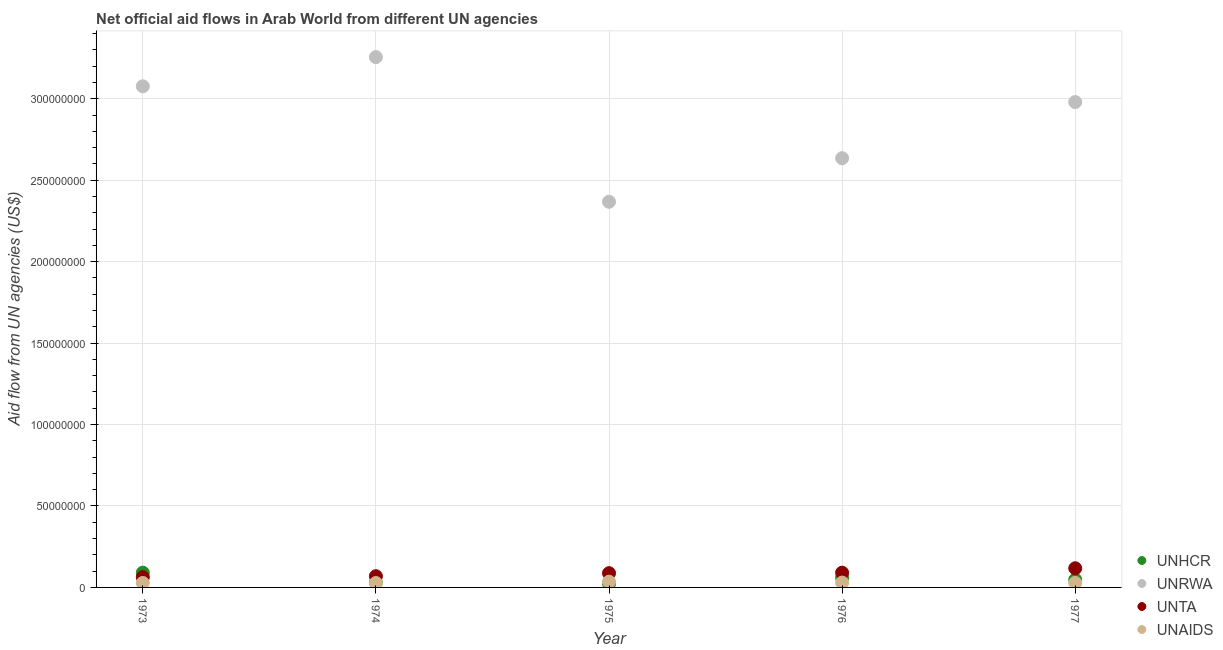How many different coloured dotlines are there?
Make the answer very short. 4. What is the amount of aid given by unhcr in 1976?
Provide a short and direct response. 5.94e+06. Across all years, what is the maximum amount of aid given by unta?
Offer a very short reply. 1.18e+07. Across all years, what is the minimum amount of aid given by unhcr?
Keep it short and to the point. 2.35e+06. In which year was the amount of aid given by unaids minimum?
Keep it short and to the point. 1974. What is the total amount of aid given by unta in the graph?
Provide a succinct answer. 4.28e+07. What is the difference between the amount of aid given by unrwa in 1973 and that in 1975?
Give a very brief answer. 7.09e+07. What is the difference between the amount of aid given by unaids in 1975 and the amount of aid given by unrwa in 1974?
Offer a very short reply. -3.22e+08. What is the average amount of aid given by unaids per year?
Your answer should be very brief. 2.95e+06. In the year 1973, what is the difference between the amount of aid given by unrwa and amount of aid given by unaids?
Your answer should be compact. 3.05e+08. In how many years, is the amount of aid given by unaids greater than 140000000 US$?
Keep it short and to the point. 0. What is the ratio of the amount of aid given by unhcr in 1975 to that in 1976?
Make the answer very short. 0.4. What is the difference between the highest and the second highest amount of aid given by unaids?
Offer a very short reply. 5.60e+05. What is the difference between the highest and the lowest amount of aid given by unta?
Make the answer very short. 5.44e+06. In how many years, is the amount of aid given by unaids greater than the average amount of aid given by unaids taken over all years?
Make the answer very short. 2. Does the amount of aid given by unta monotonically increase over the years?
Provide a short and direct response. Yes. How many dotlines are there?
Give a very brief answer. 4. Does the graph contain any zero values?
Your answer should be very brief. No. Does the graph contain grids?
Ensure brevity in your answer.  Yes. How many legend labels are there?
Provide a succinct answer. 4. What is the title of the graph?
Your answer should be compact. Net official aid flows in Arab World from different UN agencies. Does "European Union" appear as one of the legend labels in the graph?
Give a very brief answer. No. What is the label or title of the Y-axis?
Make the answer very short. Aid flow from UN agencies (US$). What is the Aid flow from UN agencies (US$) in UNHCR in 1973?
Make the answer very short. 9.06e+06. What is the Aid flow from UN agencies (US$) in UNRWA in 1973?
Your answer should be compact. 3.08e+08. What is the Aid flow from UN agencies (US$) of UNTA in 1973?
Your response must be concise. 6.33e+06. What is the Aid flow from UN agencies (US$) in UNAIDS in 1973?
Your response must be concise. 2.74e+06. What is the Aid flow from UN agencies (US$) of UNHCR in 1974?
Provide a succinct answer. 3.05e+06. What is the Aid flow from UN agencies (US$) of UNRWA in 1974?
Offer a terse response. 3.26e+08. What is the Aid flow from UN agencies (US$) in UNTA in 1974?
Offer a terse response. 6.90e+06. What is the Aid flow from UN agencies (US$) of UNAIDS in 1974?
Provide a short and direct response. 2.72e+06. What is the Aid flow from UN agencies (US$) of UNHCR in 1975?
Keep it short and to the point. 2.35e+06. What is the Aid flow from UN agencies (US$) in UNRWA in 1975?
Offer a terse response. 2.37e+08. What is the Aid flow from UN agencies (US$) of UNTA in 1975?
Provide a succinct answer. 8.75e+06. What is the Aid flow from UN agencies (US$) in UNAIDS in 1975?
Offer a terse response. 3.53e+06. What is the Aid flow from UN agencies (US$) of UNHCR in 1976?
Provide a short and direct response. 5.94e+06. What is the Aid flow from UN agencies (US$) in UNRWA in 1976?
Give a very brief answer. 2.64e+08. What is the Aid flow from UN agencies (US$) in UNTA in 1976?
Provide a short and direct response. 9.05e+06. What is the Aid flow from UN agencies (US$) of UNAIDS in 1976?
Give a very brief answer. 2.97e+06. What is the Aid flow from UN agencies (US$) in UNHCR in 1977?
Keep it short and to the point. 4.75e+06. What is the Aid flow from UN agencies (US$) in UNRWA in 1977?
Your answer should be compact. 2.98e+08. What is the Aid flow from UN agencies (US$) of UNTA in 1977?
Give a very brief answer. 1.18e+07. What is the Aid flow from UN agencies (US$) of UNAIDS in 1977?
Offer a terse response. 2.80e+06. Across all years, what is the maximum Aid flow from UN agencies (US$) of UNHCR?
Provide a short and direct response. 9.06e+06. Across all years, what is the maximum Aid flow from UN agencies (US$) in UNRWA?
Offer a terse response. 3.26e+08. Across all years, what is the maximum Aid flow from UN agencies (US$) in UNTA?
Your answer should be very brief. 1.18e+07. Across all years, what is the maximum Aid flow from UN agencies (US$) of UNAIDS?
Ensure brevity in your answer.  3.53e+06. Across all years, what is the minimum Aid flow from UN agencies (US$) of UNHCR?
Provide a succinct answer. 2.35e+06. Across all years, what is the minimum Aid flow from UN agencies (US$) of UNRWA?
Ensure brevity in your answer.  2.37e+08. Across all years, what is the minimum Aid flow from UN agencies (US$) of UNTA?
Your answer should be very brief. 6.33e+06. Across all years, what is the minimum Aid flow from UN agencies (US$) in UNAIDS?
Offer a very short reply. 2.72e+06. What is the total Aid flow from UN agencies (US$) in UNHCR in the graph?
Provide a short and direct response. 2.52e+07. What is the total Aid flow from UN agencies (US$) in UNRWA in the graph?
Make the answer very short. 1.43e+09. What is the total Aid flow from UN agencies (US$) of UNTA in the graph?
Your answer should be compact. 4.28e+07. What is the total Aid flow from UN agencies (US$) of UNAIDS in the graph?
Keep it short and to the point. 1.48e+07. What is the difference between the Aid flow from UN agencies (US$) of UNHCR in 1973 and that in 1974?
Provide a succinct answer. 6.01e+06. What is the difference between the Aid flow from UN agencies (US$) of UNRWA in 1973 and that in 1974?
Offer a very short reply. -1.79e+07. What is the difference between the Aid flow from UN agencies (US$) of UNTA in 1973 and that in 1974?
Your response must be concise. -5.70e+05. What is the difference between the Aid flow from UN agencies (US$) of UNAIDS in 1973 and that in 1974?
Ensure brevity in your answer.  2.00e+04. What is the difference between the Aid flow from UN agencies (US$) in UNHCR in 1973 and that in 1975?
Offer a very short reply. 6.71e+06. What is the difference between the Aid flow from UN agencies (US$) in UNRWA in 1973 and that in 1975?
Your response must be concise. 7.09e+07. What is the difference between the Aid flow from UN agencies (US$) in UNTA in 1973 and that in 1975?
Make the answer very short. -2.42e+06. What is the difference between the Aid flow from UN agencies (US$) in UNAIDS in 1973 and that in 1975?
Offer a very short reply. -7.90e+05. What is the difference between the Aid flow from UN agencies (US$) in UNHCR in 1973 and that in 1976?
Offer a very short reply. 3.12e+06. What is the difference between the Aid flow from UN agencies (US$) in UNRWA in 1973 and that in 1976?
Give a very brief answer. 4.42e+07. What is the difference between the Aid flow from UN agencies (US$) of UNTA in 1973 and that in 1976?
Your response must be concise. -2.72e+06. What is the difference between the Aid flow from UN agencies (US$) of UNHCR in 1973 and that in 1977?
Offer a very short reply. 4.31e+06. What is the difference between the Aid flow from UN agencies (US$) in UNRWA in 1973 and that in 1977?
Offer a very short reply. 9.68e+06. What is the difference between the Aid flow from UN agencies (US$) in UNTA in 1973 and that in 1977?
Offer a terse response. -5.44e+06. What is the difference between the Aid flow from UN agencies (US$) of UNHCR in 1974 and that in 1975?
Your answer should be compact. 7.00e+05. What is the difference between the Aid flow from UN agencies (US$) in UNRWA in 1974 and that in 1975?
Offer a terse response. 8.88e+07. What is the difference between the Aid flow from UN agencies (US$) in UNTA in 1974 and that in 1975?
Ensure brevity in your answer.  -1.85e+06. What is the difference between the Aid flow from UN agencies (US$) of UNAIDS in 1974 and that in 1975?
Give a very brief answer. -8.10e+05. What is the difference between the Aid flow from UN agencies (US$) in UNHCR in 1974 and that in 1976?
Give a very brief answer. -2.89e+06. What is the difference between the Aid flow from UN agencies (US$) of UNRWA in 1974 and that in 1976?
Provide a short and direct response. 6.20e+07. What is the difference between the Aid flow from UN agencies (US$) of UNTA in 1974 and that in 1976?
Your answer should be compact. -2.15e+06. What is the difference between the Aid flow from UN agencies (US$) in UNAIDS in 1974 and that in 1976?
Offer a very short reply. -2.50e+05. What is the difference between the Aid flow from UN agencies (US$) of UNHCR in 1974 and that in 1977?
Offer a terse response. -1.70e+06. What is the difference between the Aid flow from UN agencies (US$) in UNRWA in 1974 and that in 1977?
Give a very brief answer. 2.76e+07. What is the difference between the Aid flow from UN agencies (US$) of UNTA in 1974 and that in 1977?
Make the answer very short. -4.87e+06. What is the difference between the Aid flow from UN agencies (US$) in UNHCR in 1975 and that in 1976?
Give a very brief answer. -3.59e+06. What is the difference between the Aid flow from UN agencies (US$) in UNRWA in 1975 and that in 1976?
Give a very brief answer. -2.67e+07. What is the difference between the Aid flow from UN agencies (US$) in UNAIDS in 1975 and that in 1976?
Keep it short and to the point. 5.60e+05. What is the difference between the Aid flow from UN agencies (US$) in UNHCR in 1975 and that in 1977?
Keep it short and to the point. -2.40e+06. What is the difference between the Aid flow from UN agencies (US$) in UNRWA in 1975 and that in 1977?
Your answer should be very brief. -6.12e+07. What is the difference between the Aid flow from UN agencies (US$) in UNTA in 1975 and that in 1977?
Your answer should be compact. -3.02e+06. What is the difference between the Aid flow from UN agencies (US$) of UNAIDS in 1975 and that in 1977?
Keep it short and to the point. 7.30e+05. What is the difference between the Aid flow from UN agencies (US$) of UNHCR in 1976 and that in 1977?
Make the answer very short. 1.19e+06. What is the difference between the Aid flow from UN agencies (US$) of UNRWA in 1976 and that in 1977?
Offer a very short reply. -3.45e+07. What is the difference between the Aid flow from UN agencies (US$) in UNTA in 1976 and that in 1977?
Your response must be concise. -2.72e+06. What is the difference between the Aid flow from UN agencies (US$) in UNAIDS in 1976 and that in 1977?
Keep it short and to the point. 1.70e+05. What is the difference between the Aid flow from UN agencies (US$) in UNHCR in 1973 and the Aid flow from UN agencies (US$) in UNRWA in 1974?
Your answer should be compact. -3.17e+08. What is the difference between the Aid flow from UN agencies (US$) in UNHCR in 1973 and the Aid flow from UN agencies (US$) in UNTA in 1974?
Your answer should be very brief. 2.16e+06. What is the difference between the Aid flow from UN agencies (US$) in UNHCR in 1973 and the Aid flow from UN agencies (US$) in UNAIDS in 1974?
Ensure brevity in your answer.  6.34e+06. What is the difference between the Aid flow from UN agencies (US$) of UNRWA in 1973 and the Aid flow from UN agencies (US$) of UNTA in 1974?
Provide a short and direct response. 3.01e+08. What is the difference between the Aid flow from UN agencies (US$) in UNRWA in 1973 and the Aid flow from UN agencies (US$) in UNAIDS in 1974?
Offer a very short reply. 3.05e+08. What is the difference between the Aid flow from UN agencies (US$) in UNTA in 1973 and the Aid flow from UN agencies (US$) in UNAIDS in 1974?
Your response must be concise. 3.61e+06. What is the difference between the Aid flow from UN agencies (US$) in UNHCR in 1973 and the Aid flow from UN agencies (US$) in UNRWA in 1975?
Offer a very short reply. -2.28e+08. What is the difference between the Aid flow from UN agencies (US$) in UNHCR in 1973 and the Aid flow from UN agencies (US$) in UNTA in 1975?
Your answer should be very brief. 3.10e+05. What is the difference between the Aid flow from UN agencies (US$) in UNHCR in 1973 and the Aid flow from UN agencies (US$) in UNAIDS in 1975?
Offer a terse response. 5.53e+06. What is the difference between the Aid flow from UN agencies (US$) in UNRWA in 1973 and the Aid flow from UN agencies (US$) in UNTA in 1975?
Your answer should be very brief. 2.99e+08. What is the difference between the Aid flow from UN agencies (US$) in UNRWA in 1973 and the Aid flow from UN agencies (US$) in UNAIDS in 1975?
Make the answer very short. 3.04e+08. What is the difference between the Aid flow from UN agencies (US$) of UNTA in 1973 and the Aid flow from UN agencies (US$) of UNAIDS in 1975?
Make the answer very short. 2.80e+06. What is the difference between the Aid flow from UN agencies (US$) of UNHCR in 1973 and the Aid flow from UN agencies (US$) of UNRWA in 1976?
Provide a short and direct response. -2.54e+08. What is the difference between the Aid flow from UN agencies (US$) in UNHCR in 1973 and the Aid flow from UN agencies (US$) in UNAIDS in 1976?
Give a very brief answer. 6.09e+06. What is the difference between the Aid flow from UN agencies (US$) in UNRWA in 1973 and the Aid flow from UN agencies (US$) in UNTA in 1976?
Your response must be concise. 2.99e+08. What is the difference between the Aid flow from UN agencies (US$) of UNRWA in 1973 and the Aid flow from UN agencies (US$) of UNAIDS in 1976?
Your answer should be very brief. 3.05e+08. What is the difference between the Aid flow from UN agencies (US$) in UNTA in 1973 and the Aid flow from UN agencies (US$) in UNAIDS in 1976?
Ensure brevity in your answer.  3.36e+06. What is the difference between the Aid flow from UN agencies (US$) in UNHCR in 1973 and the Aid flow from UN agencies (US$) in UNRWA in 1977?
Offer a terse response. -2.89e+08. What is the difference between the Aid flow from UN agencies (US$) of UNHCR in 1973 and the Aid flow from UN agencies (US$) of UNTA in 1977?
Ensure brevity in your answer.  -2.71e+06. What is the difference between the Aid flow from UN agencies (US$) in UNHCR in 1973 and the Aid flow from UN agencies (US$) in UNAIDS in 1977?
Your answer should be very brief. 6.26e+06. What is the difference between the Aid flow from UN agencies (US$) of UNRWA in 1973 and the Aid flow from UN agencies (US$) of UNTA in 1977?
Your answer should be compact. 2.96e+08. What is the difference between the Aid flow from UN agencies (US$) of UNRWA in 1973 and the Aid flow from UN agencies (US$) of UNAIDS in 1977?
Ensure brevity in your answer.  3.05e+08. What is the difference between the Aid flow from UN agencies (US$) in UNTA in 1973 and the Aid flow from UN agencies (US$) in UNAIDS in 1977?
Your answer should be compact. 3.53e+06. What is the difference between the Aid flow from UN agencies (US$) in UNHCR in 1974 and the Aid flow from UN agencies (US$) in UNRWA in 1975?
Your response must be concise. -2.34e+08. What is the difference between the Aid flow from UN agencies (US$) in UNHCR in 1974 and the Aid flow from UN agencies (US$) in UNTA in 1975?
Provide a succinct answer. -5.70e+06. What is the difference between the Aid flow from UN agencies (US$) in UNHCR in 1974 and the Aid flow from UN agencies (US$) in UNAIDS in 1975?
Your response must be concise. -4.80e+05. What is the difference between the Aid flow from UN agencies (US$) of UNRWA in 1974 and the Aid flow from UN agencies (US$) of UNTA in 1975?
Ensure brevity in your answer.  3.17e+08. What is the difference between the Aid flow from UN agencies (US$) in UNRWA in 1974 and the Aid flow from UN agencies (US$) in UNAIDS in 1975?
Provide a succinct answer. 3.22e+08. What is the difference between the Aid flow from UN agencies (US$) in UNTA in 1974 and the Aid flow from UN agencies (US$) in UNAIDS in 1975?
Keep it short and to the point. 3.37e+06. What is the difference between the Aid flow from UN agencies (US$) of UNHCR in 1974 and the Aid flow from UN agencies (US$) of UNRWA in 1976?
Make the answer very short. -2.60e+08. What is the difference between the Aid flow from UN agencies (US$) in UNHCR in 1974 and the Aid flow from UN agencies (US$) in UNTA in 1976?
Ensure brevity in your answer.  -6.00e+06. What is the difference between the Aid flow from UN agencies (US$) in UNRWA in 1974 and the Aid flow from UN agencies (US$) in UNTA in 1976?
Offer a terse response. 3.17e+08. What is the difference between the Aid flow from UN agencies (US$) of UNRWA in 1974 and the Aid flow from UN agencies (US$) of UNAIDS in 1976?
Keep it short and to the point. 3.23e+08. What is the difference between the Aid flow from UN agencies (US$) of UNTA in 1974 and the Aid flow from UN agencies (US$) of UNAIDS in 1976?
Ensure brevity in your answer.  3.93e+06. What is the difference between the Aid flow from UN agencies (US$) of UNHCR in 1974 and the Aid flow from UN agencies (US$) of UNRWA in 1977?
Ensure brevity in your answer.  -2.95e+08. What is the difference between the Aid flow from UN agencies (US$) of UNHCR in 1974 and the Aid flow from UN agencies (US$) of UNTA in 1977?
Make the answer very short. -8.72e+06. What is the difference between the Aid flow from UN agencies (US$) of UNRWA in 1974 and the Aid flow from UN agencies (US$) of UNTA in 1977?
Provide a short and direct response. 3.14e+08. What is the difference between the Aid flow from UN agencies (US$) in UNRWA in 1974 and the Aid flow from UN agencies (US$) in UNAIDS in 1977?
Offer a terse response. 3.23e+08. What is the difference between the Aid flow from UN agencies (US$) of UNTA in 1974 and the Aid flow from UN agencies (US$) of UNAIDS in 1977?
Your response must be concise. 4.10e+06. What is the difference between the Aid flow from UN agencies (US$) in UNHCR in 1975 and the Aid flow from UN agencies (US$) in UNRWA in 1976?
Provide a succinct answer. -2.61e+08. What is the difference between the Aid flow from UN agencies (US$) of UNHCR in 1975 and the Aid flow from UN agencies (US$) of UNTA in 1976?
Give a very brief answer. -6.70e+06. What is the difference between the Aid flow from UN agencies (US$) of UNHCR in 1975 and the Aid flow from UN agencies (US$) of UNAIDS in 1976?
Provide a short and direct response. -6.20e+05. What is the difference between the Aid flow from UN agencies (US$) in UNRWA in 1975 and the Aid flow from UN agencies (US$) in UNTA in 1976?
Your response must be concise. 2.28e+08. What is the difference between the Aid flow from UN agencies (US$) of UNRWA in 1975 and the Aid flow from UN agencies (US$) of UNAIDS in 1976?
Ensure brevity in your answer.  2.34e+08. What is the difference between the Aid flow from UN agencies (US$) in UNTA in 1975 and the Aid flow from UN agencies (US$) in UNAIDS in 1976?
Keep it short and to the point. 5.78e+06. What is the difference between the Aid flow from UN agencies (US$) of UNHCR in 1975 and the Aid flow from UN agencies (US$) of UNRWA in 1977?
Provide a succinct answer. -2.96e+08. What is the difference between the Aid flow from UN agencies (US$) in UNHCR in 1975 and the Aid flow from UN agencies (US$) in UNTA in 1977?
Provide a succinct answer. -9.42e+06. What is the difference between the Aid flow from UN agencies (US$) of UNHCR in 1975 and the Aid flow from UN agencies (US$) of UNAIDS in 1977?
Offer a very short reply. -4.50e+05. What is the difference between the Aid flow from UN agencies (US$) of UNRWA in 1975 and the Aid flow from UN agencies (US$) of UNTA in 1977?
Keep it short and to the point. 2.25e+08. What is the difference between the Aid flow from UN agencies (US$) in UNRWA in 1975 and the Aid flow from UN agencies (US$) in UNAIDS in 1977?
Your answer should be compact. 2.34e+08. What is the difference between the Aid flow from UN agencies (US$) of UNTA in 1975 and the Aid flow from UN agencies (US$) of UNAIDS in 1977?
Provide a succinct answer. 5.95e+06. What is the difference between the Aid flow from UN agencies (US$) of UNHCR in 1976 and the Aid flow from UN agencies (US$) of UNRWA in 1977?
Keep it short and to the point. -2.92e+08. What is the difference between the Aid flow from UN agencies (US$) of UNHCR in 1976 and the Aid flow from UN agencies (US$) of UNTA in 1977?
Offer a very short reply. -5.83e+06. What is the difference between the Aid flow from UN agencies (US$) of UNHCR in 1976 and the Aid flow from UN agencies (US$) of UNAIDS in 1977?
Make the answer very short. 3.14e+06. What is the difference between the Aid flow from UN agencies (US$) in UNRWA in 1976 and the Aid flow from UN agencies (US$) in UNTA in 1977?
Keep it short and to the point. 2.52e+08. What is the difference between the Aid flow from UN agencies (US$) in UNRWA in 1976 and the Aid flow from UN agencies (US$) in UNAIDS in 1977?
Provide a succinct answer. 2.61e+08. What is the difference between the Aid flow from UN agencies (US$) in UNTA in 1976 and the Aid flow from UN agencies (US$) in UNAIDS in 1977?
Your answer should be very brief. 6.25e+06. What is the average Aid flow from UN agencies (US$) in UNHCR per year?
Make the answer very short. 5.03e+06. What is the average Aid flow from UN agencies (US$) in UNRWA per year?
Ensure brevity in your answer.  2.86e+08. What is the average Aid flow from UN agencies (US$) of UNTA per year?
Make the answer very short. 8.56e+06. What is the average Aid flow from UN agencies (US$) of UNAIDS per year?
Keep it short and to the point. 2.95e+06. In the year 1973, what is the difference between the Aid flow from UN agencies (US$) of UNHCR and Aid flow from UN agencies (US$) of UNRWA?
Offer a terse response. -2.99e+08. In the year 1973, what is the difference between the Aid flow from UN agencies (US$) of UNHCR and Aid flow from UN agencies (US$) of UNTA?
Offer a very short reply. 2.73e+06. In the year 1973, what is the difference between the Aid flow from UN agencies (US$) in UNHCR and Aid flow from UN agencies (US$) in UNAIDS?
Your answer should be compact. 6.32e+06. In the year 1973, what is the difference between the Aid flow from UN agencies (US$) of UNRWA and Aid flow from UN agencies (US$) of UNTA?
Your answer should be compact. 3.01e+08. In the year 1973, what is the difference between the Aid flow from UN agencies (US$) of UNRWA and Aid flow from UN agencies (US$) of UNAIDS?
Your answer should be compact. 3.05e+08. In the year 1973, what is the difference between the Aid flow from UN agencies (US$) in UNTA and Aid flow from UN agencies (US$) in UNAIDS?
Ensure brevity in your answer.  3.59e+06. In the year 1974, what is the difference between the Aid flow from UN agencies (US$) in UNHCR and Aid flow from UN agencies (US$) in UNRWA?
Your answer should be compact. -3.23e+08. In the year 1974, what is the difference between the Aid flow from UN agencies (US$) of UNHCR and Aid flow from UN agencies (US$) of UNTA?
Provide a short and direct response. -3.85e+06. In the year 1974, what is the difference between the Aid flow from UN agencies (US$) of UNHCR and Aid flow from UN agencies (US$) of UNAIDS?
Your response must be concise. 3.30e+05. In the year 1974, what is the difference between the Aid flow from UN agencies (US$) of UNRWA and Aid flow from UN agencies (US$) of UNTA?
Ensure brevity in your answer.  3.19e+08. In the year 1974, what is the difference between the Aid flow from UN agencies (US$) in UNRWA and Aid flow from UN agencies (US$) in UNAIDS?
Offer a very short reply. 3.23e+08. In the year 1974, what is the difference between the Aid flow from UN agencies (US$) of UNTA and Aid flow from UN agencies (US$) of UNAIDS?
Your answer should be very brief. 4.18e+06. In the year 1975, what is the difference between the Aid flow from UN agencies (US$) in UNHCR and Aid flow from UN agencies (US$) in UNRWA?
Provide a short and direct response. -2.34e+08. In the year 1975, what is the difference between the Aid flow from UN agencies (US$) in UNHCR and Aid flow from UN agencies (US$) in UNTA?
Your response must be concise. -6.40e+06. In the year 1975, what is the difference between the Aid flow from UN agencies (US$) in UNHCR and Aid flow from UN agencies (US$) in UNAIDS?
Give a very brief answer. -1.18e+06. In the year 1975, what is the difference between the Aid flow from UN agencies (US$) of UNRWA and Aid flow from UN agencies (US$) of UNTA?
Provide a succinct answer. 2.28e+08. In the year 1975, what is the difference between the Aid flow from UN agencies (US$) in UNRWA and Aid flow from UN agencies (US$) in UNAIDS?
Your answer should be compact. 2.33e+08. In the year 1975, what is the difference between the Aid flow from UN agencies (US$) of UNTA and Aid flow from UN agencies (US$) of UNAIDS?
Offer a very short reply. 5.22e+06. In the year 1976, what is the difference between the Aid flow from UN agencies (US$) of UNHCR and Aid flow from UN agencies (US$) of UNRWA?
Give a very brief answer. -2.58e+08. In the year 1976, what is the difference between the Aid flow from UN agencies (US$) of UNHCR and Aid flow from UN agencies (US$) of UNTA?
Ensure brevity in your answer.  -3.11e+06. In the year 1976, what is the difference between the Aid flow from UN agencies (US$) in UNHCR and Aid flow from UN agencies (US$) in UNAIDS?
Offer a terse response. 2.97e+06. In the year 1976, what is the difference between the Aid flow from UN agencies (US$) in UNRWA and Aid flow from UN agencies (US$) in UNTA?
Your response must be concise. 2.54e+08. In the year 1976, what is the difference between the Aid flow from UN agencies (US$) in UNRWA and Aid flow from UN agencies (US$) in UNAIDS?
Provide a short and direct response. 2.61e+08. In the year 1976, what is the difference between the Aid flow from UN agencies (US$) in UNTA and Aid flow from UN agencies (US$) in UNAIDS?
Keep it short and to the point. 6.08e+06. In the year 1977, what is the difference between the Aid flow from UN agencies (US$) of UNHCR and Aid flow from UN agencies (US$) of UNRWA?
Ensure brevity in your answer.  -2.93e+08. In the year 1977, what is the difference between the Aid flow from UN agencies (US$) of UNHCR and Aid flow from UN agencies (US$) of UNTA?
Keep it short and to the point. -7.02e+06. In the year 1977, what is the difference between the Aid flow from UN agencies (US$) of UNHCR and Aid flow from UN agencies (US$) of UNAIDS?
Your response must be concise. 1.95e+06. In the year 1977, what is the difference between the Aid flow from UN agencies (US$) in UNRWA and Aid flow from UN agencies (US$) in UNTA?
Your answer should be compact. 2.86e+08. In the year 1977, what is the difference between the Aid flow from UN agencies (US$) of UNRWA and Aid flow from UN agencies (US$) of UNAIDS?
Offer a very short reply. 2.95e+08. In the year 1977, what is the difference between the Aid flow from UN agencies (US$) in UNTA and Aid flow from UN agencies (US$) in UNAIDS?
Your answer should be compact. 8.97e+06. What is the ratio of the Aid flow from UN agencies (US$) of UNHCR in 1973 to that in 1974?
Make the answer very short. 2.97. What is the ratio of the Aid flow from UN agencies (US$) in UNRWA in 1973 to that in 1974?
Give a very brief answer. 0.95. What is the ratio of the Aid flow from UN agencies (US$) in UNTA in 1973 to that in 1974?
Provide a short and direct response. 0.92. What is the ratio of the Aid flow from UN agencies (US$) of UNAIDS in 1973 to that in 1974?
Give a very brief answer. 1.01. What is the ratio of the Aid flow from UN agencies (US$) of UNHCR in 1973 to that in 1975?
Offer a very short reply. 3.86. What is the ratio of the Aid flow from UN agencies (US$) of UNRWA in 1973 to that in 1975?
Your response must be concise. 1.3. What is the ratio of the Aid flow from UN agencies (US$) of UNTA in 1973 to that in 1975?
Your answer should be compact. 0.72. What is the ratio of the Aid flow from UN agencies (US$) of UNAIDS in 1973 to that in 1975?
Your answer should be very brief. 0.78. What is the ratio of the Aid flow from UN agencies (US$) in UNHCR in 1973 to that in 1976?
Your response must be concise. 1.53. What is the ratio of the Aid flow from UN agencies (US$) of UNRWA in 1973 to that in 1976?
Make the answer very short. 1.17. What is the ratio of the Aid flow from UN agencies (US$) in UNTA in 1973 to that in 1976?
Keep it short and to the point. 0.7. What is the ratio of the Aid flow from UN agencies (US$) of UNAIDS in 1973 to that in 1976?
Ensure brevity in your answer.  0.92. What is the ratio of the Aid flow from UN agencies (US$) of UNHCR in 1973 to that in 1977?
Your response must be concise. 1.91. What is the ratio of the Aid flow from UN agencies (US$) of UNRWA in 1973 to that in 1977?
Provide a succinct answer. 1.03. What is the ratio of the Aid flow from UN agencies (US$) of UNTA in 1973 to that in 1977?
Your answer should be very brief. 0.54. What is the ratio of the Aid flow from UN agencies (US$) in UNAIDS in 1973 to that in 1977?
Your response must be concise. 0.98. What is the ratio of the Aid flow from UN agencies (US$) of UNHCR in 1974 to that in 1975?
Give a very brief answer. 1.3. What is the ratio of the Aid flow from UN agencies (US$) in UNRWA in 1974 to that in 1975?
Provide a succinct answer. 1.38. What is the ratio of the Aid flow from UN agencies (US$) of UNTA in 1974 to that in 1975?
Keep it short and to the point. 0.79. What is the ratio of the Aid flow from UN agencies (US$) of UNAIDS in 1974 to that in 1975?
Ensure brevity in your answer.  0.77. What is the ratio of the Aid flow from UN agencies (US$) of UNHCR in 1974 to that in 1976?
Keep it short and to the point. 0.51. What is the ratio of the Aid flow from UN agencies (US$) in UNRWA in 1974 to that in 1976?
Your answer should be compact. 1.24. What is the ratio of the Aid flow from UN agencies (US$) in UNTA in 1974 to that in 1976?
Offer a terse response. 0.76. What is the ratio of the Aid flow from UN agencies (US$) in UNAIDS in 1974 to that in 1976?
Your answer should be very brief. 0.92. What is the ratio of the Aid flow from UN agencies (US$) in UNHCR in 1974 to that in 1977?
Give a very brief answer. 0.64. What is the ratio of the Aid flow from UN agencies (US$) of UNRWA in 1974 to that in 1977?
Your answer should be very brief. 1.09. What is the ratio of the Aid flow from UN agencies (US$) of UNTA in 1974 to that in 1977?
Your answer should be compact. 0.59. What is the ratio of the Aid flow from UN agencies (US$) in UNAIDS in 1974 to that in 1977?
Your response must be concise. 0.97. What is the ratio of the Aid flow from UN agencies (US$) in UNHCR in 1975 to that in 1976?
Your answer should be compact. 0.4. What is the ratio of the Aid flow from UN agencies (US$) in UNRWA in 1975 to that in 1976?
Your answer should be compact. 0.9. What is the ratio of the Aid flow from UN agencies (US$) of UNTA in 1975 to that in 1976?
Your response must be concise. 0.97. What is the ratio of the Aid flow from UN agencies (US$) in UNAIDS in 1975 to that in 1976?
Offer a terse response. 1.19. What is the ratio of the Aid flow from UN agencies (US$) of UNHCR in 1975 to that in 1977?
Provide a succinct answer. 0.49. What is the ratio of the Aid flow from UN agencies (US$) of UNRWA in 1975 to that in 1977?
Offer a very short reply. 0.79. What is the ratio of the Aid flow from UN agencies (US$) in UNTA in 1975 to that in 1977?
Provide a succinct answer. 0.74. What is the ratio of the Aid flow from UN agencies (US$) of UNAIDS in 1975 to that in 1977?
Make the answer very short. 1.26. What is the ratio of the Aid flow from UN agencies (US$) in UNHCR in 1976 to that in 1977?
Your response must be concise. 1.25. What is the ratio of the Aid flow from UN agencies (US$) of UNRWA in 1976 to that in 1977?
Offer a very short reply. 0.88. What is the ratio of the Aid flow from UN agencies (US$) in UNTA in 1976 to that in 1977?
Ensure brevity in your answer.  0.77. What is the ratio of the Aid flow from UN agencies (US$) in UNAIDS in 1976 to that in 1977?
Your answer should be very brief. 1.06. What is the difference between the highest and the second highest Aid flow from UN agencies (US$) of UNHCR?
Your answer should be very brief. 3.12e+06. What is the difference between the highest and the second highest Aid flow from UN agencies (US$) in UNRWA?
Give a very brief answer. 1.79e+07. What is the difference between the highest and the second highest Aid flow from UN agencies (US$) of UNTA?
Provide a succinct answer. 2.72e+06. What is the difference between the highest and the second highest Aid flow from UN agencies (US$) of UNAIDS?
Your answer should be compact. 5.60e+05. What is the difference between the highest and the lowest Aid flow from UN agencies (US$) of UNHCR?
Keep it short and to the point. 6.71e+06. What is the difference between the highest and the lowest Aid flow from UN agencies (US$) in UNRWA?
Your response must be concise. 8.88e+07. What is the difference between the highest and the lowest Aid flow from UN agencies (US$) of UNTA?
Your answer should be very brief. 5.44e+06. What is the difference between the highest and the lowest Aid flow from UN agencies (US$) of UNAIDS?
Keep it short and to the point. 8.10e+05. 